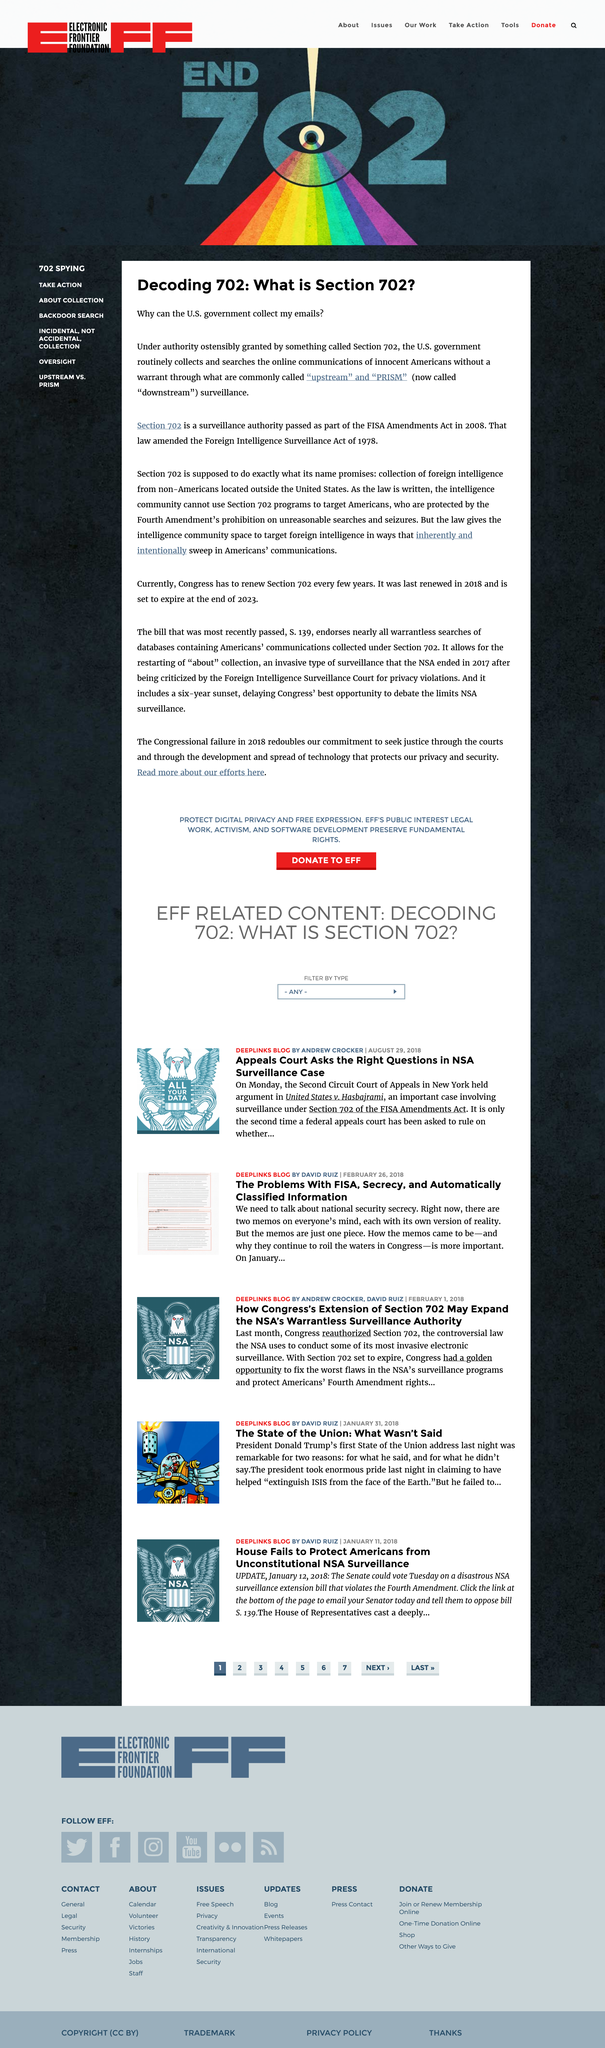Give some essential details in this illustration. Section 702, which was passed as part of the FISA Amendments Act of 2008, allows the U.S. government to collect foreign intelligence information from non-U.S. persons located outside of the United States. Section 702 allows for the collection and surveillance of online communications in the United States without a warrant, which is a violation of Americans' Fourth Amendment rights and undermines the constitutional principle of individualized suspicion. Downstream surveillance is now known to have been previously referred to as Upstream and PRISM surveillance. 